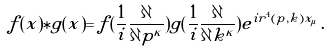<formula> <loc_0><loc_0><loc_500><loc_500>f ( x ) \ast g ( x ) = f ( \frac { 1 } { i } \frac { \partial } { \partial p ^ { \kappa } } ) g ( \frac { 1 } { i } \frac { \partial } { \partial k ^ { \kappa } } ) e ^ { i r ^ { 4 } ( p , k ) x _ { \mu } } \, .</formula> 